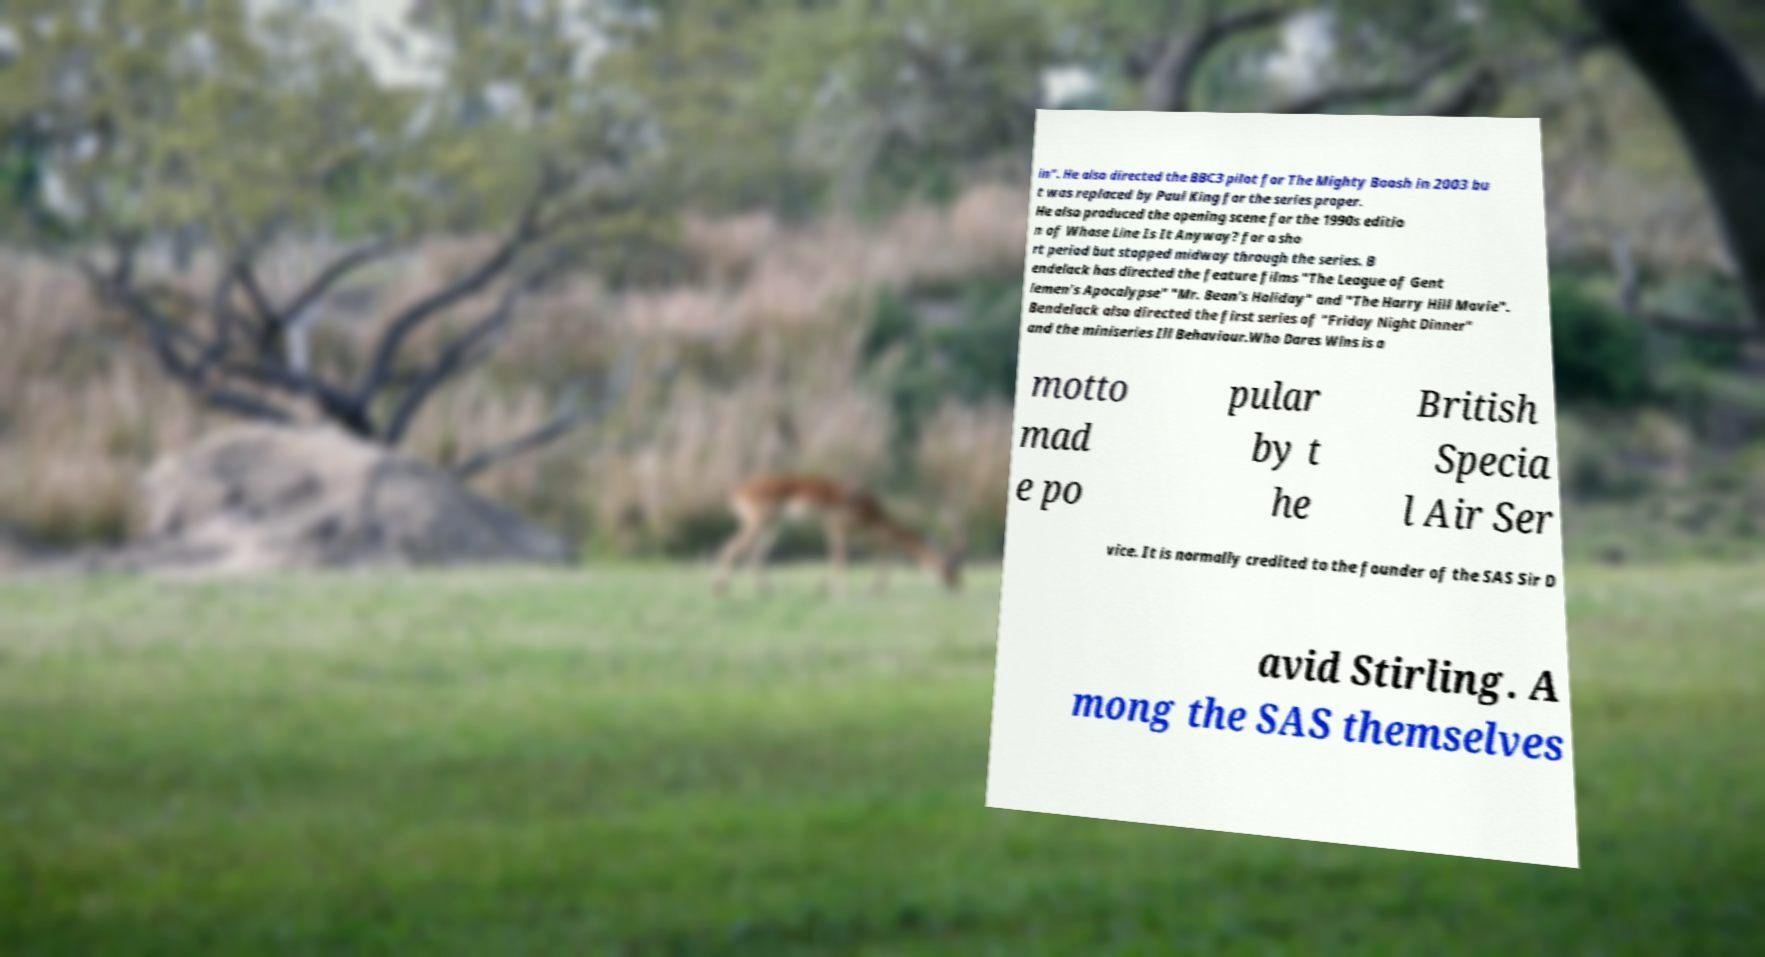There's text embedded in this image that I need extracted. Can you transcribe it verbatim? in". He also directed the BBC3 pilot for The Mighty Boosh in 2003 bu t was replaced by Paul King for the series proper. He also produced the opening scene for the 1990s editio n of Whose Line Is It Anyway? for a sho rt period but stopped midway through the series. B endelack has directed the feature films "The League of Gent lemen's Apocalypse" "Mr. Bean's Holiday" and "The Harry Hill Movie". Bendelack also directed the first series of "Friday Night Dinner" and the miniseries Ill Behaviour.Who Dares Wins is a motto mad e po pular by t he British Specia l Air Ser vice. It is normally credited to the founder of the SAS Sir D avid Stirling. A mong the SAS themselves 